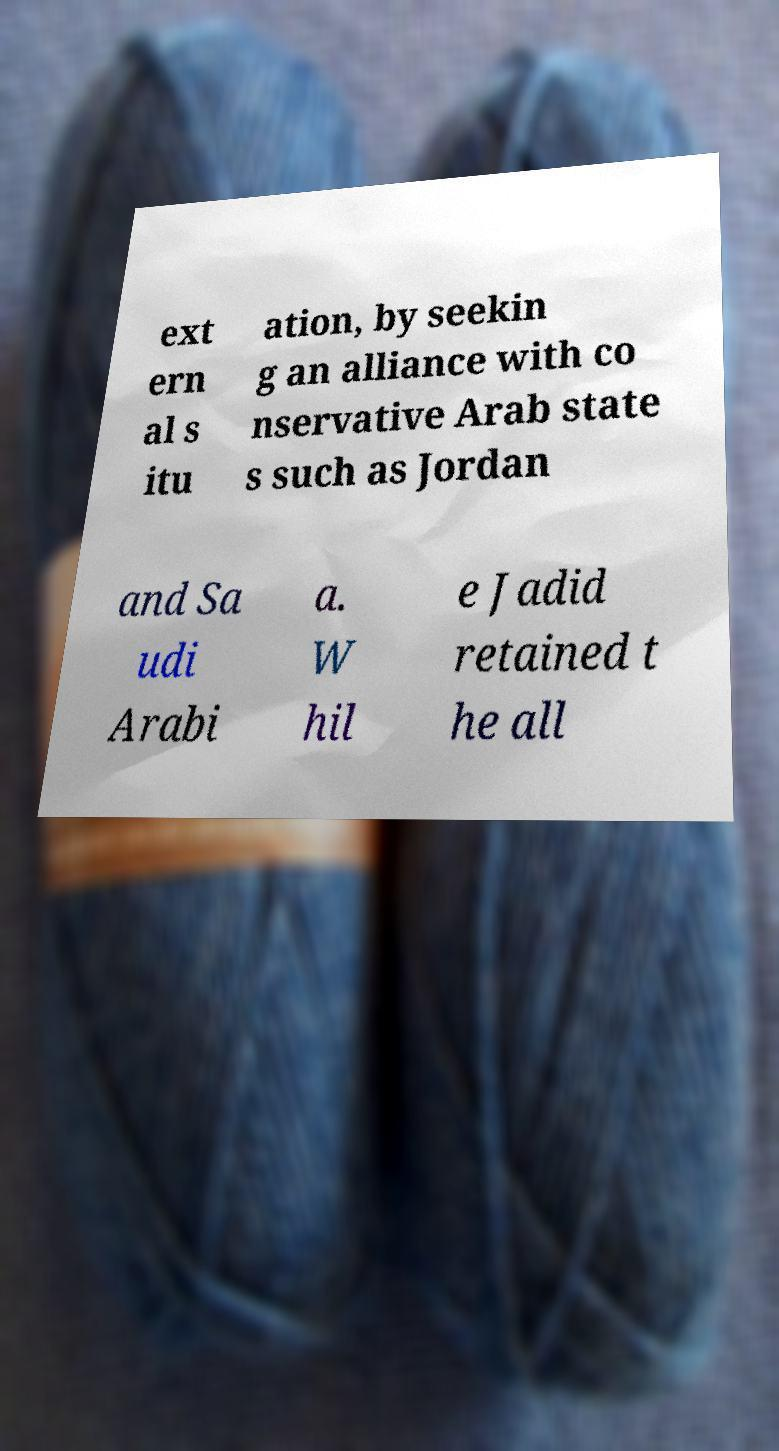For documentation purposes, I need the text within this image transcribed. Could you provide that? ext ern al s itu ation, by seekin g an alliance with co nservative Arab state s such as Jordan and Sa udi Arabi a. W hil e Jadid retained t he all 